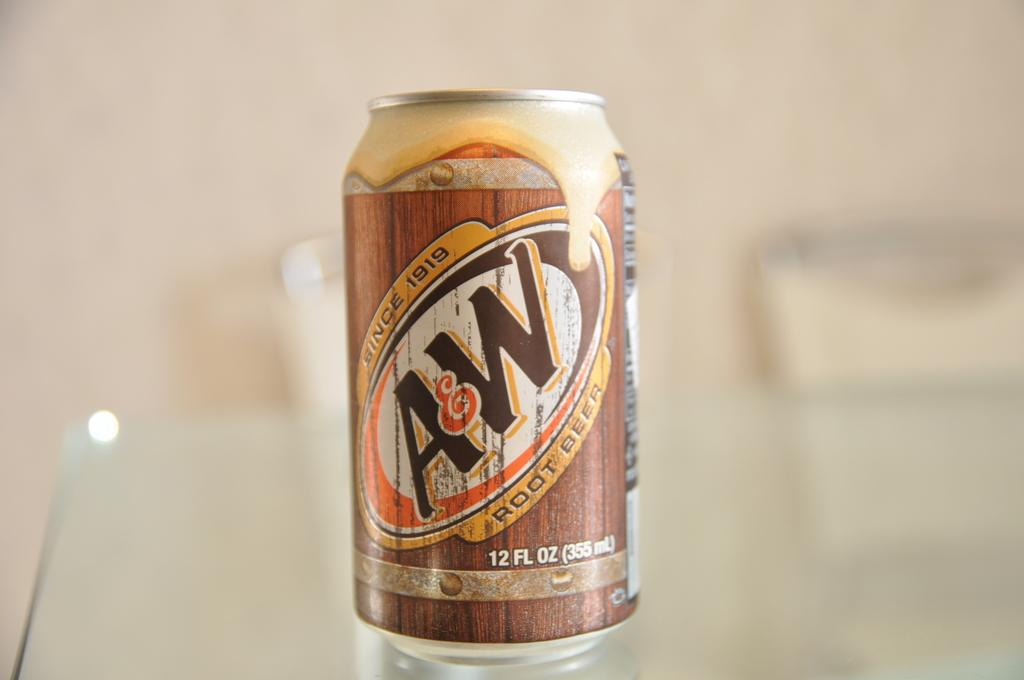<image>
Present a compact description of the photo's key features. A 12 ounce can of A&W root beer, which has been around since 1919 